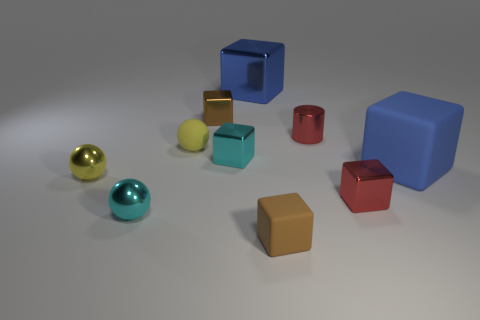Subtract all yellow rubber spheres. How many spheres are left? 2 Subtract all brown blocks. How many blocks are left? 4 Subtract 2 balls. How many balls are left? 1 Subtract all green spheres. Subtract all brown cubes. How many spheres are left? 3 Subtract all purple cylinders. How many brown cubes are left? 2 Subtract all tiny gray blocks. Subtract all tiny red shiny things. How many objects are left? 8 Add 3 red shiny cubes. How many red shiny cubes are left? 4 Add 2 yellow spheres. How many yellow spheres exist? 4 Subtract 0 yellow cylinders. How many objects are left? 10 Subtract all balls. How many objects are left? 7 